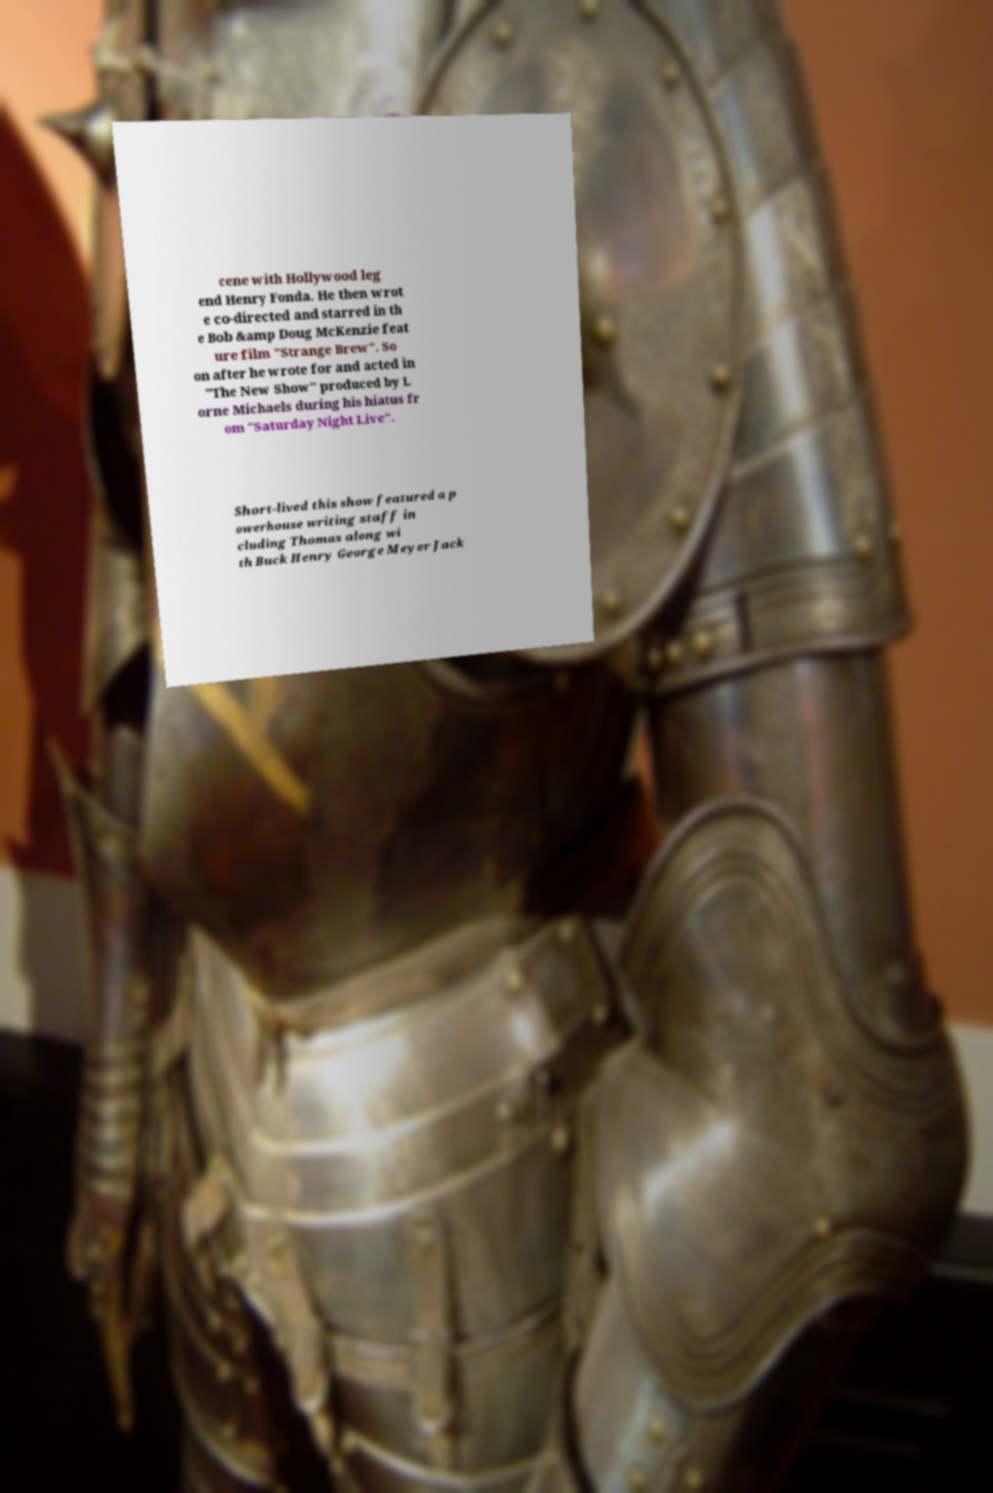Could you assist in decoding the text presented in this image and type it out clearly? cene with Hollywood leg end Henry Fonda. He then wrot e co-directed and starred in th e Bob &amp Doug McKenzie feat ure film "Strange Brew". So on after he wrote for and acted in "The New Show" produced by L orne Michaels during his hiatus fr om "Saturday Night Live". Short-lived this show featured a p owerhouse writing staff in cluding Thomas along wi th Buck Henry George Meyer Jack 